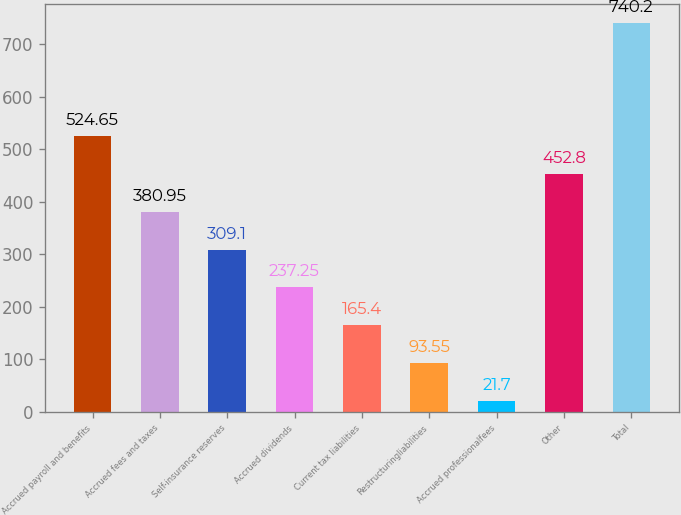Convert chart to OTSL. <chart><loc_0><loc_0><loc_500><loc_500><bar_chart><fcel>Accrued payroll and benefits<fcel>Accrued fees and taxes<fcel>Self-insurance reserves<fcel>Accrued dividends<fcel>Current tax liabilities<fcel>Restructuringliabilities<fcel>Accrued professionalfees<fcel>Other<fcel>Total<nl><fcel>524.65<fcel>380.95<fcel>309.1<fcel>237.25<fcel>165.4<fcel>93.55<fcel>21.7<fcel>452.8<fcel>740.2<nl></chart> 